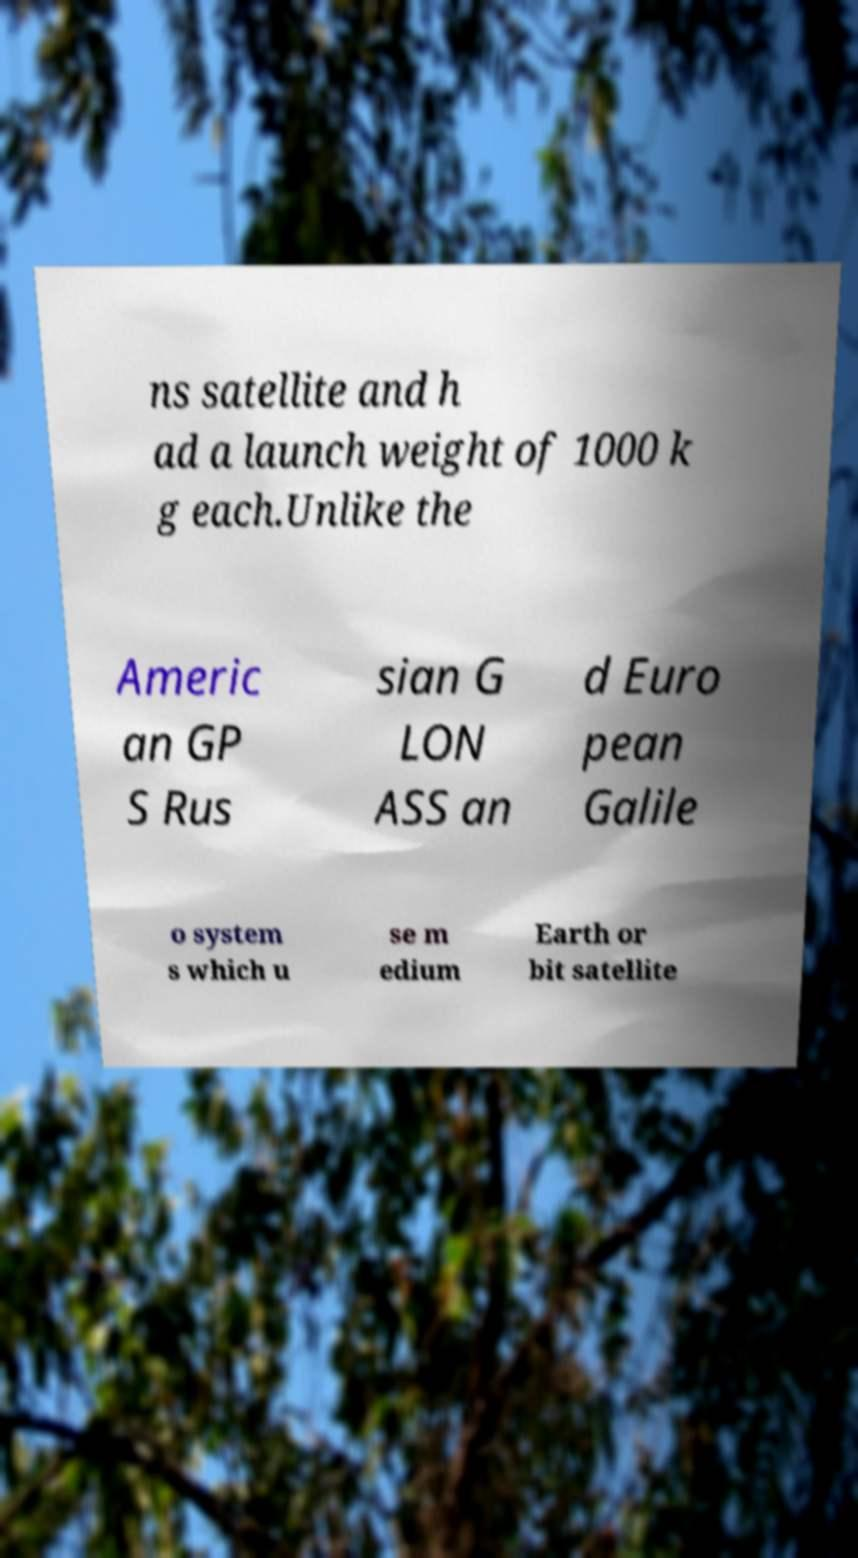For documentation purposes, I need the text within this image transcribed. Could you provide that? ns satellite and h ad a launch weight of 1000 k g each.Unlike the Americ an GP S Rus sian G LON ASS an d Euro pean Galile o system s which u se m edium Earth or bit satellite 